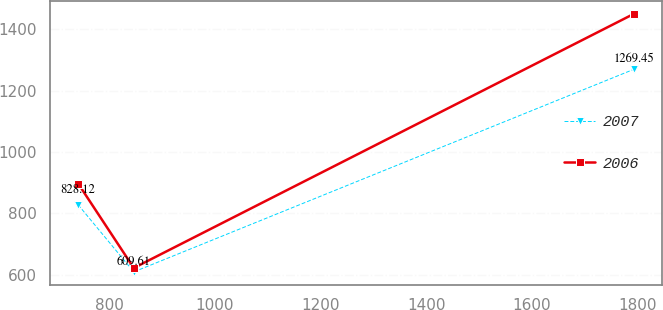Convert chart. <chart><loc_0><loc_0><loc_500><loc_500><line_chart><ecel><fcel>2007<fcel>2006<nl><fcel>741.3<fcel>828.12<fcel>897.1<nl><fcel>846.49<fcel>609.61<fcel>622.39<nl><fcel>1793.17<fcel>1269.45<fcel>1449.96<nl></chart> 